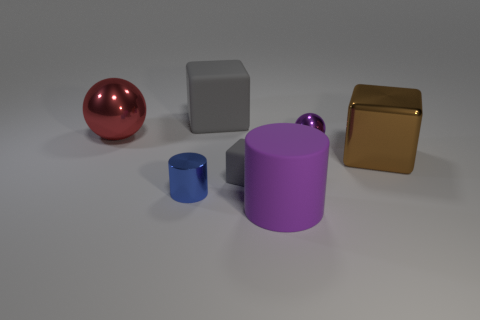Subtract all tiny rubber cubes. How many cubes are left? 2 Subtract all gray cylinders. How many gray cubes are left? 2 Add 1 big brown blocks. How many objects exist? 8 Subtract all cylinders. How many objects are left? 5 Subtract all yellow cubes. Subtract all yellow cylinders. How many cubes are left? 3 Subtract all brown cubes. Subtract all gray matte cubes. How many objects are left? 4 Add 5 purple metal objects. How many purple metal objects are left? 6 Add 2 big brown matte cylinders. How many big brown matte cylinders exist? 2 Subtract 0 yellow balls. How many objects are left? 7 